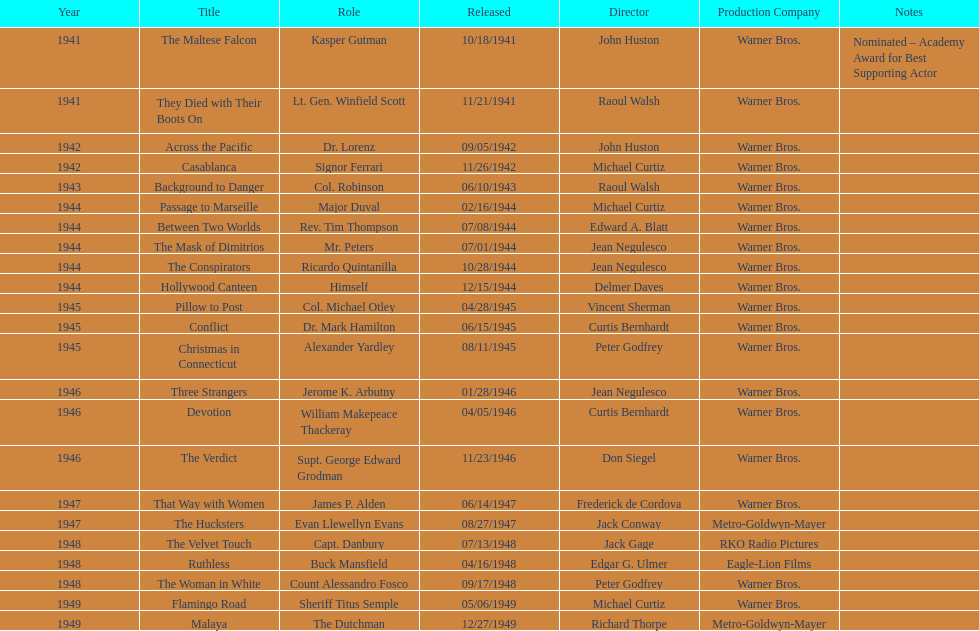How many films has he appeared in from 1941-1949? 23. 